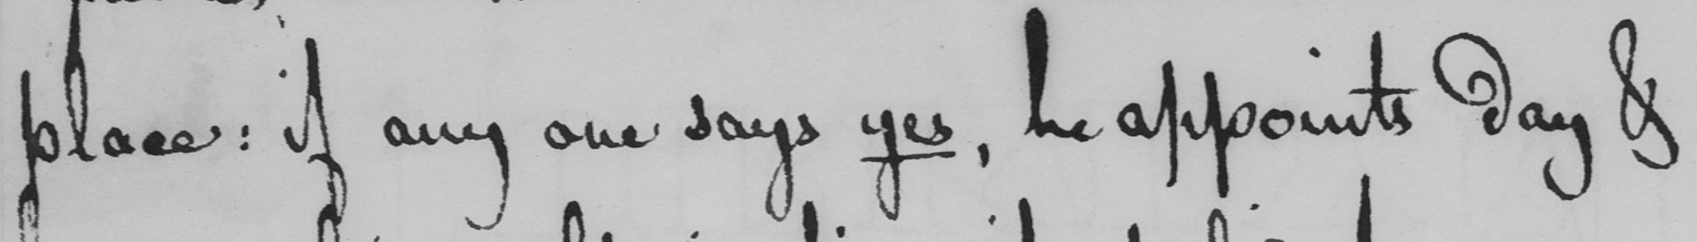Please provide the text content of this handwritten line. place: if any one says yes, he appoints day & 